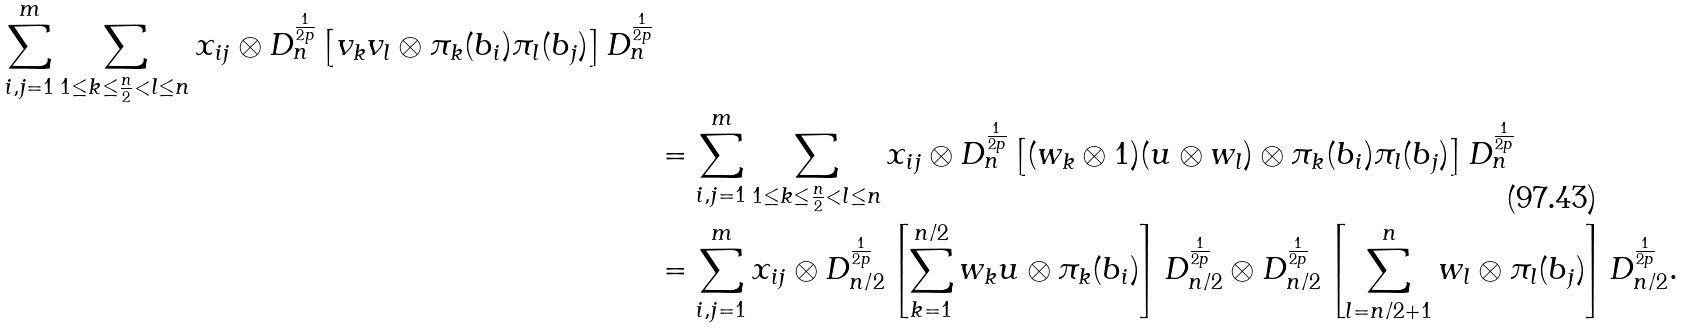<formula> <loc_0><loc_0><loc_500><loc_500>{ \sum ^ { m } _ { i , j = 1 } \sum _ { 1 \leq k \leq \frac { n } { 2 } < l \leq n } x _ { i j } \otimes D ^ { \frac { 1 } { 2 p } } _ { n } \left [ v _ { k } v _ { l } \otimes \pi _ { k } ( b _ { i } ) \pi _ { l } ( b _ { j } ) \right ] D ^ { \frac { 1 } { 2 p } } _ { n } } \\ & = \sum ^ { m } _ { i , j = 1 } \sum _ { 1 \leq k \leq \frac { n } { 2 } < l \leq n } x _ { i j } \otimes D ^ { \frac { 1 } { 2 p } } _ { n } \left [ ( w _ { k } \otimes 1 ) ( u \otimes w _ { l } ) \otimes \pi _ { k } ( b _ { i } ) \pi _ { l } ( b _ { j } ) \right ] D ^ { \frac { 1 } { 2 p } } _ { n } \\ & = \sum ^ { m } _ { i , j = 1 } x _ { i j } \otimes D ^ { \frac { 1 } { 2 p } } _ { n / 2 } \left [ \sum ^ { n / 2 } _ { k = 1 } w _ { k } u \otimes \pi _ { k } ( b _ { i } ) \right ] D ^ { \frac { 1 } { 2 p } } _ { n / 2 } \otimes D ^ { \frac { 1 } { 2 p } } _ { n / 2 } \left [ \sum ^ { n } _ { l = n / 2 + 1 } w _ { l } \otimes \pi _ { l } ( b _ { j } ) \right ] D ^ { \frac { 1 } { 2 p } } _ { n / 2 } .</formula> 